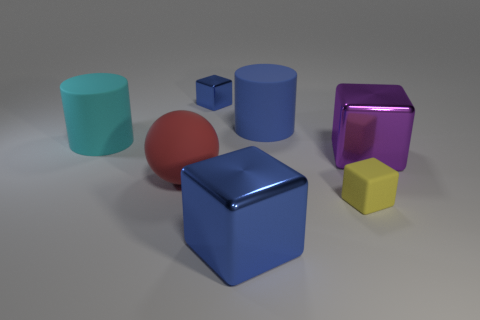Is there a yellow block that has the same size as the purple metallic block?
Ensure brevity in your answer.  No. The matte cube is what color?
Give a very brief answer. Yellow. Is the size of the blue matte cylinder the same as the yellow block?
Your answer should be very brief. No. How many things are either blue metallic things or small blocks?
Make the answer very short. 3. Are there an equal number of large blue cubes that are behind the ball and big blocks?
Offer a terse response. No. Is there a tiny cube that is in front of the large red sphere that is in front of the big cube behind the big blue block?
Your answer should be compact. Yes. The tiny block that is the same material as the big red ball is what color?
Make the answer very short. Yellow. Is the color of the large cube that is left of the yellow matte thing the same as the small metal object?
Ensure brevity in your answer.  Yes. How many balls are either cyan things or large purple metallic things?
Offer a terse response. 0. How big is the cube that is behind the big metal thing to the right of the small block in front of the purple thing?
Your answer should be very brief. Small. 